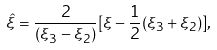Convert formula to latex. <formula><loc_0><loc_0><loc_500><loc_500>\hat { \xi } = \frac { 2 } { ( \xi _ { 3 } - \xi _ { 2 } ) } [ \xi - \frac { 1 } { 2 } ( \xi _ { 3 } + \xi _ { 2 } ) ] ,</formula> 